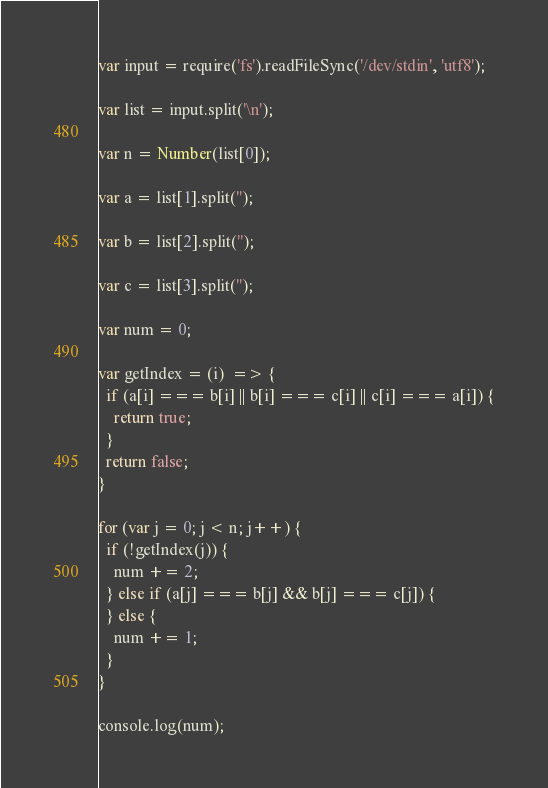Convert code to text. <code><loc_0><loc_0><loc_500><loc_500><_JavaScript_>
var input = require('fs').readFileSync('/dev/stdin', 'utf8');

var list = input.split('\n');

var n = Number(list[0]);

var a = list[1].split('');

var b = list[2].split('');

var c = list[3].split('');

var num = 0;

var getIndex = (i)  => {
  if (a[i] === b[i] || b[i] === c[i] || c[i] === a[i]) {
    return true;
  }
  return false;
}

for (var j = 0; j < n; j++) {
  if (!getIndex(j)) {
    num += 2;
  } else if (a[j] === b[j] && b[j] === c[j]) {
  } else {
    num += 1;
  }
}

console.log(num);
</code> 